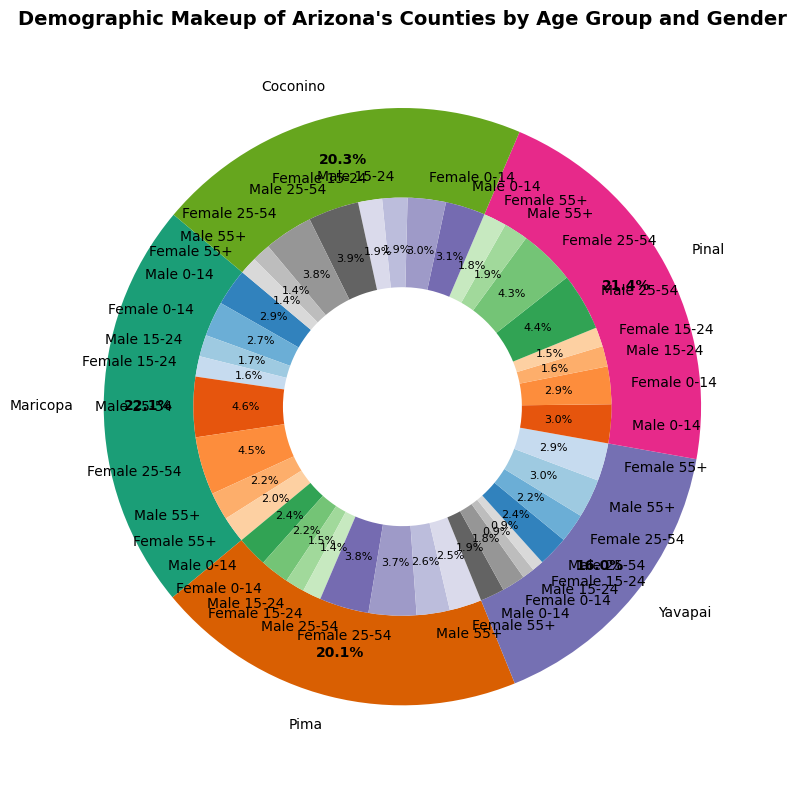What percentage of the population in Maricopa County is aged 0-14? To find the percentage of the population aged 0-14 in Maricopa County, sum the percentages of both males and females in that age group. This can be found by adding 12.5% (males) and 11.8% (females).
Answer: 24.3% What's the total percentage of the population in Coconino County aged 15-24 and 25-54? Add the percentages of both age groups, considering both males and females. For 15-24: (8.5% males + 8.1% females = 16.6%), for 25-54: (17.1% males + 16.5% females = 33.6%). Now, sum these totals: 16.6% + 33.6%.
Answer: 50.2% Which county has the highest percentage of its population aged 55+? Compare the total percentage of the population aged 55+ among all counties by summing the percentages of males and females for each county and then identifying the highest. 
- Maricopa: 9.4% (males) + 8.9% (females) = 18.3% 
- Pima: 11.2% (males) + 10.9% (females) = 22.1%
- Yavapai: 13.1% (males) + 12.8% (females) = 25.9%
- Pinal: 8.2% (males) + 7.8% (females) = 16.0%
- Coconino: 6.3% (males) + 5.9% (females) = 12.2%
Yavapai County has the highest percentage.
Answer: Yavapai Which gender has a higher percentage in the 25-54 age group in Maricopa County, and what's the percentage difference? Compare the percentages of males and females. Males: 20.3%, Females: 19.6%. Calculate the difference: 20.3% - 19.6%. This means males have a higher percentage by 0.7%.
Answer: Males, 0.7% In Pinal County, what percentage of the population is male? Sum the male percentages of all age groups in Pinal County. (0-14: 13.1%) + (15-24: 6.9%) + (25-54: 19.4%) + (55+: 8.2%). The total is 13.1% + 6.9% + 19.4% + 8.2%.
Answer: 47.6% What is the combined percentage of people aged 0-24 in Yavapai County? Sum the percentages of both 0-14 and 15-24 age groups for both males and females: (0-14: 8.2% males + 7.9% females = 16.1%) and (15-24: 4.1% males + 3.9% females = 8.0%). Now, sum these totals: 16.1% + 8.0%.
Answer: 24.1% Compare the demographic makeup of males aged 55+ in Pima and Coconino counties. Which county has a higher percentage? Look at the percentages of males aged 55+ for Pima (11.2%) and for Coconino (6.3%). Pima County has a higher percentage.
Answer: Pima What is the visual representation (color) used for Yavapai County in the pie chart? Observing the outer segment color associated with the label "Yavapai" on the pie chart indicates the color represented in the legend. Given the use of 'Dark2' colormap, Yavapai is likely in a specific distinguishable color among the set.
Answer: One of the specific distinguishable colors (unique hue from Dark2 colormap) How does the population percentage of females aged 0-14 in Maricopa compare to that in Pinal? Compare the given percentages: Maricopa (11.8%) and Pinal (12.7%). Pinal has a higher percentage than Maricopa.
Answer: Pinal has a higher percentage 